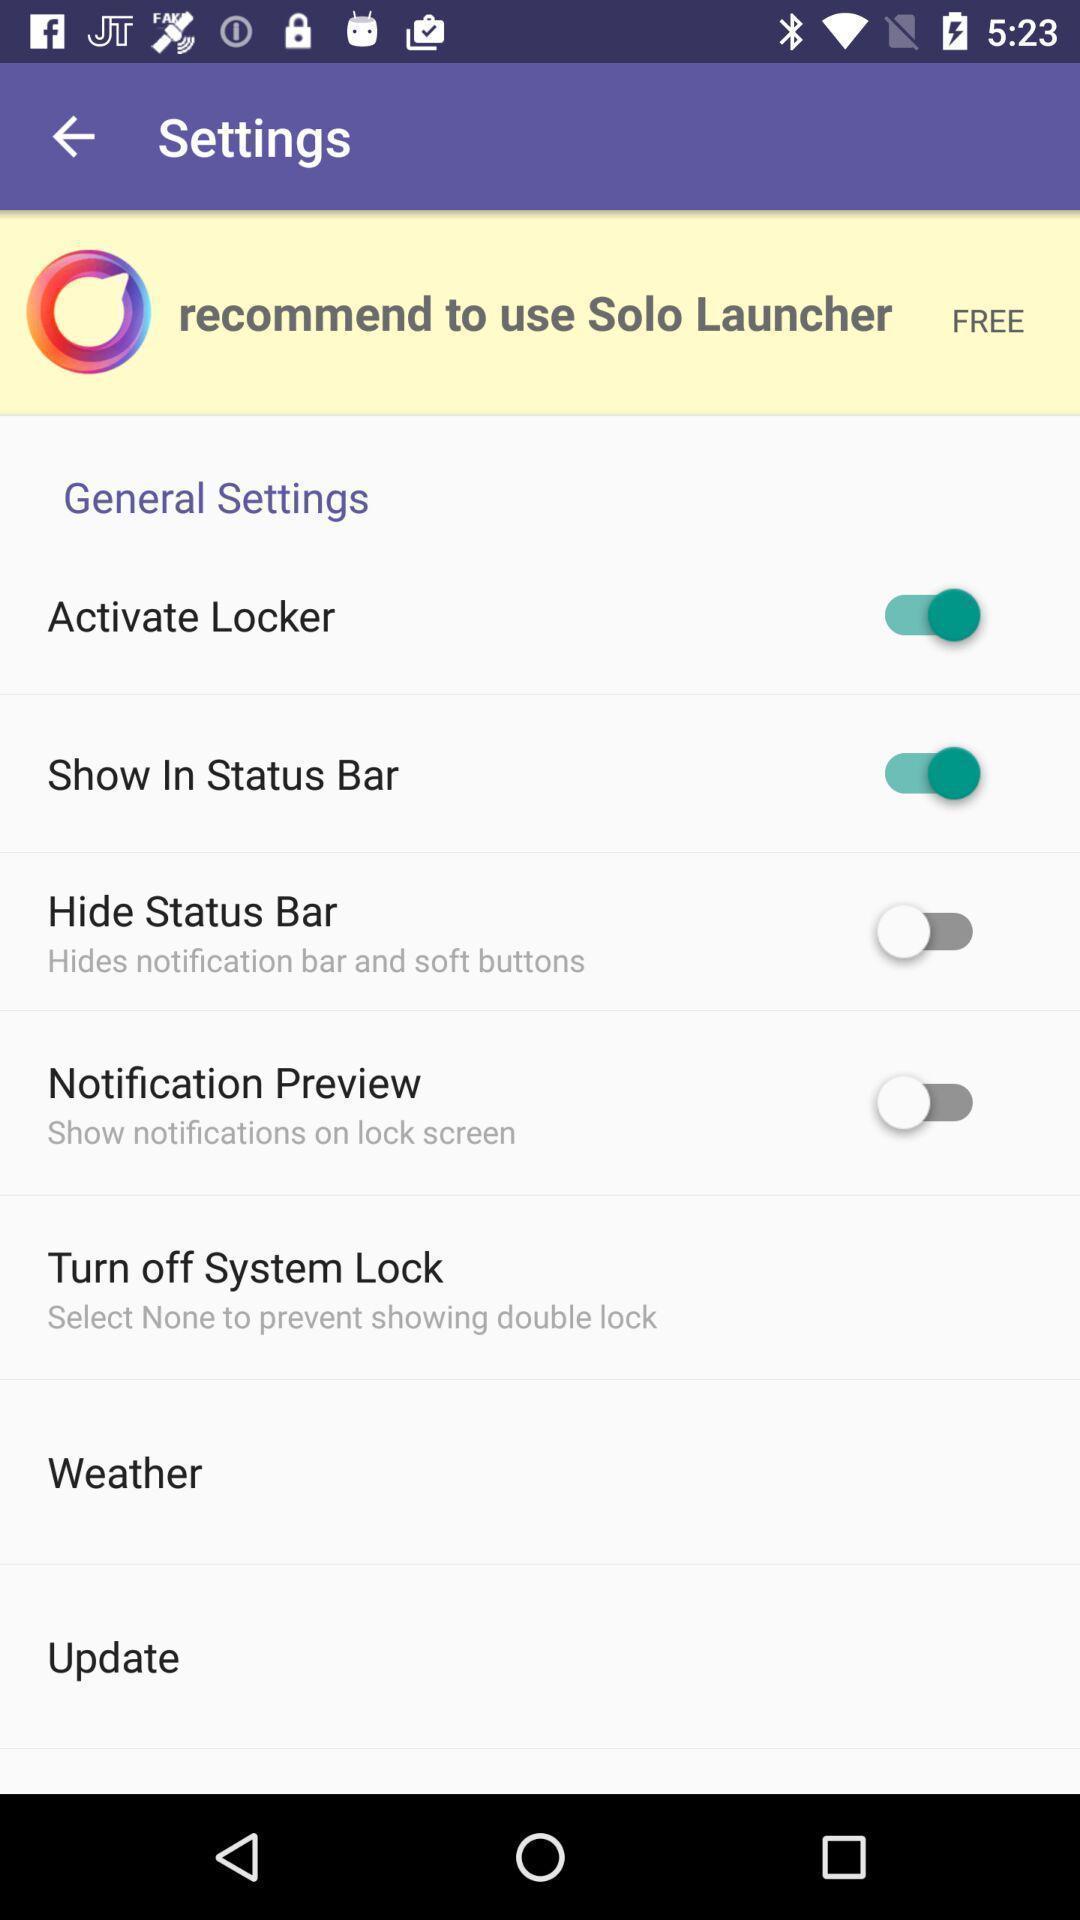Provide a textual representation of this image. Settings page with different options. 